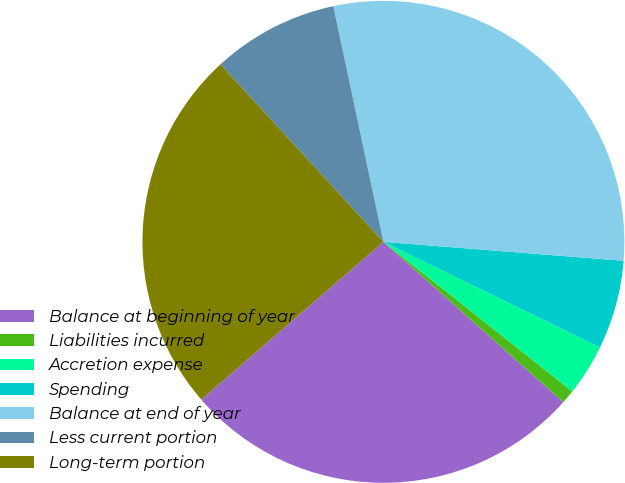Convert chart. <chart><loc_0><loc_0><loc_500><loc_500><pie_chart><fcel>Balance at beginning of year<fcel>Liabilities incurred<fcel>Accretion expense<fcel>Spending<fcel>Balance at end of year<fcel>Less current portion<fcel>Long-term portion<nl><fcel>27.06%<fcel>0.92%<fcel>3.44%<fcel>5.97%<fcel>29.59%<fcel>8.49%<fcel>24.54%<nl></chart> 